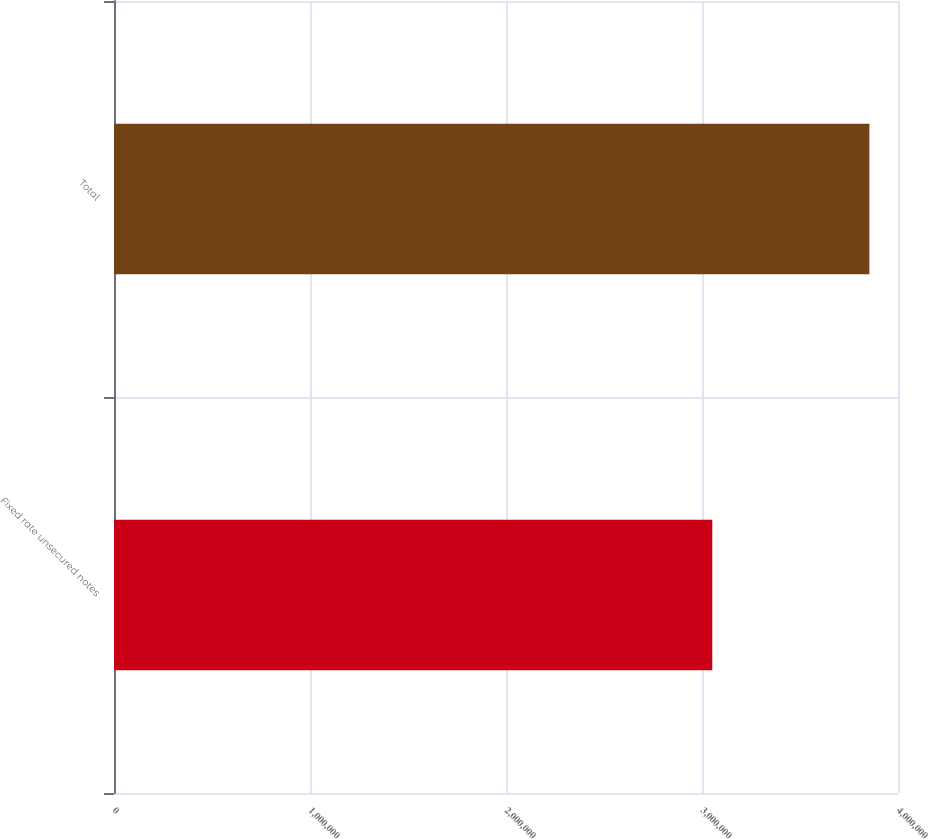Convert chart to OTSL. <chart><loc_0><loc_0><loc_500><loc_500><bar_chart><fcel>Fixed rate unsecured notes<fcel>Total<nl><fcel>3.05246e+06<fcel>3.85403e+06<nl></chart> 